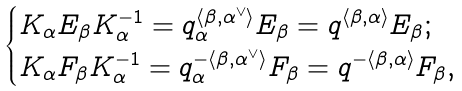<formula> <loc_0><loc_0><loc_500><loc_500>\begin{cases} K _ { \alpha } E _ { \beta } K _ { \alpha } ^ { - 1 } = q _ { \alpha } ^ { \langle \beta , \alpha ^ { \vee } \rangle } E _ { \beta } = q ^ { \langle \beta , \alpha \rangle } E _ { \beta } ; \\ K _ { \alpha } F _ { \beta } K _ { \alpha } ^ { - 1 } = q _ { \alpha } ^ { - \langle \beta , \alpha ^ { \vee } \rangle } F _ { \beta } = q ^ { - \langle \beta , \alpha \rangle } F _ { \beta } , \end{cases}</formula> 